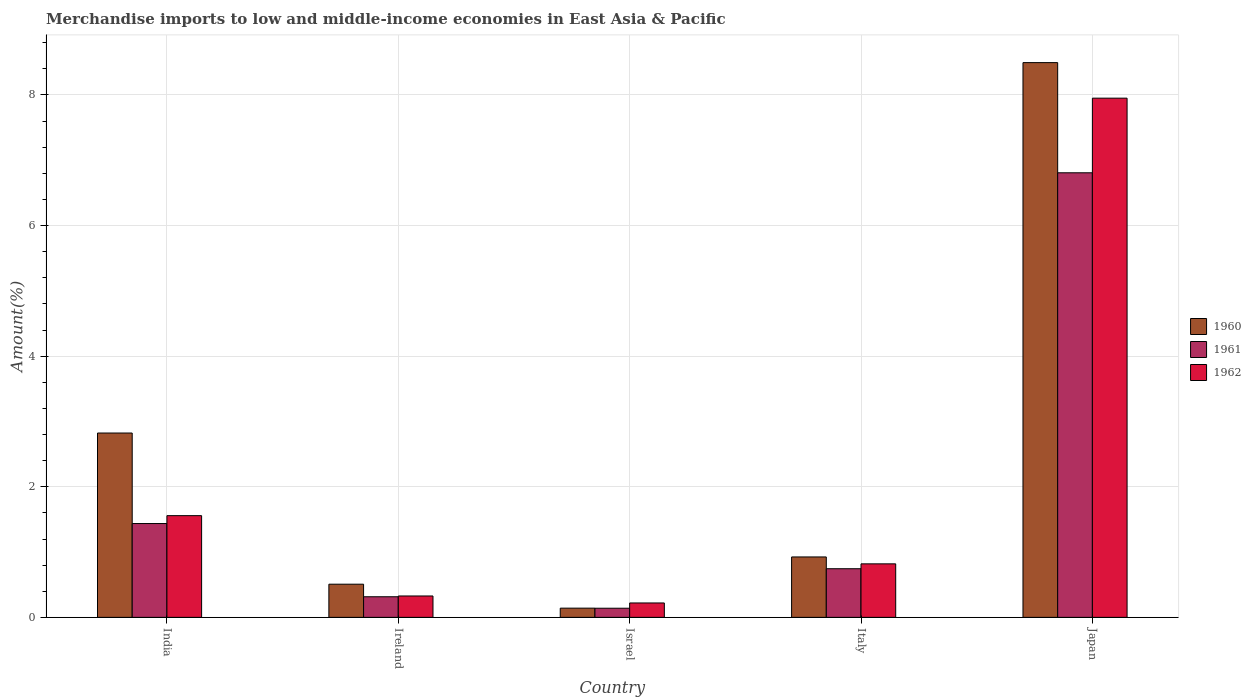How many different coloured bars are there?
Offer a terse response. 3. How many groups of bars are there?
Provide a succinct answer. 5. Are the number of bars per tick equal to the number of legend labels?
Provide a short and direct response. Yes. How many bars are there on the 4th tick from the left?
Provide a short and direct response. 3. How many bars are there on the 3rd tick from the right?
Keep it short and to the point. 3. What is the label of the 3rd group of bars from the left?
Your answer should be very brief. Israel. What is the percentage of amount earned from merchandise imports in 1962 in Japan?
Make the answer very short. 7.95. Across all countries, what is the maximum percentage of amount earned from merchandise imports in 1960?
Your response must be concise. 8.5. Across all countries, what is the minimum percentage of amount earned from merchandise imports in 1962?
Your answer should be very brief. 0.22. In which country was the percentage of amount earned from merchandise imports in 1962 maximum?
Offer a terse response. Japan. What is the total percentage of amount earned from merchandise imports in 1960 in the graph?
Ensure brevity in your answer.  12.89. What is the difference between the percentage of amount earned from merchandise imports in 1961 in Ireland and that in Italy?
Provide a short and direct response. -0.43. What is the difference between the percentage of amount earned from merchandise imports in 1962 in Ireland and the percentage of amount earned from merchandise imports in 1961 in India?
Make the answer very short. -1.11. What is the average percentage of amount earned from merchandise imports in 1962 per country?
Make the answer very short. 2.18. What is the difference between the percentage of amount earned from merchandise imports of/in 1962 and percentage of amount earned from merchandise imports of/in 1961 in Ireland?
Make the answer very short. 0.01. In how many countries, is the percentage of amount earned from merchandise imports in 1960 greater than 6 %?
Make the answer very short. 1. What is the ratio of the percentage of amount earned from merchandise imports in 1962 in Israel to that in Italy?
Offer a very short reply. 0.27. Is the percentage of amount earned from merchandise imports in 1962 in Israel less than that in Italy?
Your response must be concise. Yes. Is the difference between the percentage of amount earned from merchandise imports in 1962 in India and Ireland greater than the difference between the percentage of amount earned from merchandise imports in 1961 in India and Ireland?
Offer a terse response. Yes. What is the difference between the highest and the second highest percentage of amount earned from merchandise imports in 1961?
Your answer should be very brief. -0.69. What is the difference between the highest and the lowest percentage of amount earned from merchandise imports in 1962?
Keep it short and to the point. 7.73. In how many countries, is the percentage of amount earned from merchandise imports in 1961 greater than the average percentage of amount earned from merchandise imports in 1961 taken over all countries?
Provide a succinct answer. 1. What does the 2nd bar from the left in Ireland represents?
Provide a short and direct response. 1961. How many bars are there?
Offer a very short reply. 15. Does the graph contain any zero values?
Your answer should be very brief. No. What is the title of the graph?
Your answer should be very brief. Merchandise imports to low and middle-income economies in East Asia & Pacific. What is the label or title of the X-axis?
Offer a very short reply. Country. What is the label or title of the Y-axis?
Make the answer very short. Amount(%). What is the Amount(%) in 1960 in India?
Offer a very short reply. 2.82. What is the Amount(%) of 1961 in India?
Give a very brief answer. 1.44. What is the Amount(%) of 1962 in India?
Your answer should be compact. 1.56. What is the Amount(%) in 1960 in Ireland?
Your response must be concise. 0.51. What is the Amount(%) in 1961 in Ireland?
Provide a succinct answer. 0.32. What is the Amount(%) of 1962 in Ireland?
Keep it short and to the point. 0.33. What is the Amount(%) of 1960 in Israel?
Provide a short and direct response. 0.14. What is the Amount(%) in 1961 in Israel?
Offer a very short reply. 0.14. What is the Amount(%) of 1962 in Israel?
Your answer should be compact. 0.22. What is the Amount(%) of 1960 in Italy?
Your answer should be very brief. 0.93. What is the Amount(%) in 1961 in Italy?
Offer a very short reply. 0.74. What is the Amount(%) of 1962 in Italy?
Ensure brevity in your answer.  0.82. What is the Amount(%) in 1960 in Japan?
Offer a very short reply. 8.5. What is the Amount(%) in 1961 in Japan?
Provide a succinct answer. 6.81. What is the Amount(%) of 1962 in Japan?
Make the answer very short. 7.95. Across all countries, what is the maximum Amount(%) in 1960?
Keep it short and to the point. 8.5. Across all countries, what is the maximum Amount(%) in 1961?
Ensure brevity in your answer.  6.81. Across all countries, what is the maximum Amount(%) in 1962?
Your answer should be very brief. 7.95. Across all countries, what is the minimum Amount(%) in 1960?
Provide a succinct answer. 0.14. Across all countries, what is the minimum Amount(%) in 1961?
Give a very brief answer. 0.14. Across all countries, what is the minimum Amount(%) of 1962?
Offer a very short reply. 0.22. What is the total Amount(%) in 1960 in the graph?
Provide a short and direct response. 12.89. What is the total Amount(%) in 1961 in the graph?
Give a very brief answer. 9.45. What is the total Amount(%) of 1962 in the graph?
Make the answer very short. 10.88. What is the difference between the Amount(%) in 1960 in India and that in Ireland?
Ensure brevity in your answer.  2.31. What is the difference between the Amount(%) in 1961 in India and that in Ireland?
Offer a terse response. 1.12. What is the difference between the Amount(%) in 1962 in India and that in Ireland?
Make the answer very short. 1.23. What is the difference between the Amount(%) in 1960 in India and that in Israel?
Offer a terse response. 2.68. What is the difference between the Amount(%) of 1961 in India and that in Israel?
Provide a short and direct response. 1.3. What is the difference between the Amount(%) in 1962 in India and that in Israel?
Your answer should be compact. 1.34. What is the difference between the Amount(%) of 1960 in India and that in Italy?
Make the answer very short. 1.9. What is the difference between the Amount(%) in 1961 in India and that in Italy?
Your answer should be very brief. 0.69. What is the difference between the Amount(%) of 1962 in India and that in Italy?
Offer a terse response. 0.74. What is the difference between the Amount(%) in 1960 in India and that in Japan?
Ensure brevity in your answer.  -5.67. What is the difference between the Amount(%) in 1961 in India and that in Japan?
Keep it short and to the point. -5.37. What is the difference between the Amount(%) in 1962 in India and that in Japan?
Provide a succinct answer. -6.39. What is the difference between the Amount(%) in 1960 in Ireland and that in Israel?
Ensure brevity in your answer.  0.37. What is the difference between the Amount(%) in 1961 in Ireland and that in Israel?
Offer a very short reply. 0.18. What is the difference between the Amount(%) of 1962 in Ireland and that in Israel?
Make the answer very short. 0.11. What is the difference between the Amount(%) of 1960 in Ireland and that in Italy?
Offer a terse response. -0.42. What is the difference between the Amount(%) of 1961 in Ireland and that in Italy?
Ensure brevity in your answer.  -0.43. What is the difference between the Amount(%) in 1962 in Ireland and that in Italy?
Offer a terse response. -0.49. What is the difference between the Amount(%) of 1960 in Ireland and that in Japan?
Provide a short and direct response. -7.99. What is the difference between the Amount(%) in 1961 in Ireland and that in Japan?
Provide a succinct answer. -6.49. What is the difference between the Amount(%) of 1962 in Ireland and that in Japan?
Your answer should be compact. -7.62. What is the difference between the Amount(%) of 1960 in Israel and that in Italy?
Provide a succinct answer. -0.78. What is the difference between the Amount(%) in 1961 in Israel and that in Italy?
Provide a succinct answer. -0.6. What is the difference between the Amount(%) in 1962 in Israel and that in Italy?
Provide a succinct answer. -0.6. What is the difference between the Amount(%) of 1960 in Israel and that in Japan?
Provide a short and direct response. -8.35. What is the difference between the Amount(%) in 1961 in Israel and that in Japan?
Your answer should be very brief. -6.67. What is the difference between the Amount(%) of 1962 in Israel and that in Japan?
Offer a terse response. -7.73. What is the difference between the Amount(%) in 1960 in Italy and that in Japan?
Your answer should be compact. -7.57. What is the difference between the Amount(%) of 1961 in Italy and that in Japan?
Keep it short and to the point. -6.06. What is the difference between the Amount(%) of 1962 in Italy and that in Japan?
Your response must be concise. -7.13. What is the difference between the Amount(%) of 1960 in India and the Amount(%) of 1961 in Ireland?
Keep it short and to the point. 2.51. What is the difference between the Amount(%) of 1960 in India and the Amount(%) of 1962 in Ireland?
Ensure brevity in your answer.  2.5. What is the difference between the Amount(%) in 1961 in India and the Amount(%) in 1962 in Ireland?
Provide a short and direct response. 1.11. What is the difference between the Amount(%) of 1960 in India and the Amount(%) of 1961 in Israel?
Keep it short and to the point. 2.68. What is the difference between the Amount(%) of 1960 in India and the Amount(%) of 1962 in Israel?
Ensure brevity in your answer.  2.6. What is the difference between the Amount(%) of 1961 in India and the Amount(%) of 1962 in Israel?
Provide a succinct answer. 1.22. What is the difference between the Amount(%) in 1960 in India and the Amount(%) in 1961 in Italy?
Ensure brevity in your answer.  2.08. What is the difference between the Amount(%) in 1960 in India and the Amount(%) in 1962 in Italy?
Keep it short and to the point. 2. What is the difference between the Amount(%) of 1961 in India and the Amount(%) of 1962 in Italy?
Ensure brevity in your answer.  0.62. What is the difference between the Amount(%) in 1960 in India and the Amount(%) in 1961 in Japan?
Make the answer very short. -3.99. What is the difference between the Amount(%) of 1960 in India and the Amount(%) of 1962 in Japan?
Your response must be concise. -5.13. What is the difference between the Amount(%) of 1961 in India and the Amount(%) of 1962 in Japan?
Keep it short and to the point. -6.51. What is the difference between the Amount(%) of 1960 in Ireland and the Amount(%) of 1961 in Israel?
Make the answer very short. 0.37. What is the difference between the Amount(%) in 1960 in Ireland and the Amount(%) in 1962 in Israel?
Your answer should be compact. 0.29. What is the difference between the Amount(%) in 1961 in Ireland and the Amount(%) in 1962 in Israel?
Make the answer very short. 0.1. What is the difference between the Amount(%) in 1960 in Ireland and the Amount(%) in 1961 in Italy?
Ensure brevity in your answer.  -0.24. What is the difference between the Amount(%) of 1960 in Ireland and the Amount(%) of 1962 in Italy?
Give a very brief answer. -0.31. What is the difference between the Amount(%) in 1961 in Ireland and the Amount(%) in 1962 in Italy?
Offer a terse response. -0.5. What is the difference between the Amount(%) of 1960 in Ireland and the Amount(%) of 1961 in Japan?
Make the answer very short. -6.3. What is the difference between the Amount(%) in 1960 in Ireland and the Amount(%) in 1962 in Japan?
Provide a succinct answer. -7.44. What is the difference between the Amount(%) in 1961 in Ireland and the Amount(%) in 1962 in Japan?
Ensure brevity in your answer.  -7.64. What is the difference between the Amount(%) of 1960 in Israel and the Amount(%) of 1961 in Italy?
Make the answer very short. -0.6. What is the difference between the Amount(%) of 1960 in Israel and the Amount(%) of 1962 in Italy?
Provide a short and direct response. -0.68. What is the difference between the Amount(%) of 1961 in Israel and the Amount(%) of 1962 in Italy?
Your answer should be compact. -0.68. What is the difference between the Amount(%) in 1960 in Israel and the Amount(%) in 1961 in Japan?
Give a very brief answer. -6.67. What is the difference between the Amount(%) of 1960 in Israel and the Amount(%) of 1962 in Japan?
Your response must be concise. -7.81. What is the difference between the Amount(%) of 1961 in Israel and the Amount(%) of 1962 in Japan?
Keep it short and to the point. -7.81. What is the difference between the Amount(%) in 1960 in Italy and the Amount(%) in 1961 in Japan?
Provide a succinct answer. -5.88. What is the difference between the Amount(%) of 1960 in Italy and the Amount(%) of 1962 in Japan?
Keep it short and to the point. -7.03. What is the difference between the Amount(%) in 1961 in Italy and the Amount(%) in 1962 in Japan?
Your response must be concise. -7.21. What is the average Amount(%) in 1960 per country?
Keep it short and to the point. 2.58. What is the average Amount(%) of 1961 per country?
Make the answer very short. 1.89. What is the average Amount(%) of 1962 per country?
Make the answer very short. 2.18. What is the difference between the Amount(%) in 1960 and Amount(%) in 1961 in India?
Your answer should be very brief. 1.39. What is the difference between the Amount(%) in 1960 and Amount(%) in 1962 in India?
Keep it short and to the point. 1.27. What is the difference between the Amount(%) in 1961 and Amount(%) in 1962 in India?
Ensure brevity in your answer.  -0.12. What is the difference between the Amount(%) in 1960 and Amount(%) in 1961 in Ireland?
Ensure brevity in your answer.  0.19. What is the difference between the Amount(%) in 1960 and Amount(%) in 1962 in Ireland?
Give a very brief answer. 0.18. What is the difference between the Amount(%) in 1961 and Amount(%) in 1962 in Ireland?
Your answer should be compact. -0.01. What is the difference between the Amount(%) in 1960 and Amount(%) in 1961 in Israel?
Your answer should be compact. 0. What is the difference between the Amount(%) of 1960 and Amount(%) of 1962 in Israel?
Provide a succinct answer. -0.08. What is the difference between the Amount(%) of 1961 and Amount(%) of 1962 in Israel?
Make the answer very short. -0.08. What is the difference between the Amount(%) of 1960 and Amount(%) of 1961 in Italy?
Give a very brief answer. 0.18. What is the difference between the Amount(%) in 1960 and Amount(%) in 1962 in Italy?
Your answer should be very brief. 0.11. What is the difference between the Amount(%) in 1961 and Amount(%) in 1962 in Italy?
Give a very brief answer. -0.07. What is the difference between the Amount(%) of 1960 and Amount(%) of 1961 in Japan?
Offer a very short reply. 1.69. What is the difference between the Amount(%) in 1960 and Amount(%) in 1962 in Japan?
Offer a terse response. 0.54. What is the difference between the Amount(%) of 1961 and Amount(%) of 1962 in Japan?
Ensure brevity in your answer.  -1.14. What is the ratio of the Amount(%) of 1960 in India to that in Ireland?
Provide a short and direct response. 5.56. What is the ratio of the Amount(%) of 1961 in India to that in Ireland?
Your answer should be very brief. 4.55. What is the ratio of the Amount(%) of 1962 in India to that in Ireland?
Ensure brevity in your answer.  4.76. What is the ratio of the Amount(%) in 1960 in India to that in Israel?
Offer a terse response. 20.01. What is the ratio of the Amount(%) in 1961 in India to that in Israel?
Your answer should be compact. 10.28. What is the ratio of the Amount(%) of 1962 in India to that in Israel?
Ensure brevity in your answer.  7.06. What is the ratio of the Amount(%) in 1960 in India to that in Italy?
Your answer should be very brief. 3.05. What is the ratio of the Amount(%) in 1961 in India to that in Italy?
Provide a succinct answer. 1.93. What is the ratio of the Amount(%) of 1962 in India to that in Italy?
Provide a succinct answer. 1.9. What is the ratio of the Amount(%) in 1960 in India to that in Japan?
Ensure brevity in your answer.  0.33. What is the ratio of the Amount(%) of 1961 in India to that in Japan?
Offer a terse response. 0.21. What is the ratio of the Amount(%) in 1962 in India to that in Japan?
Offer a terse response. 0.2. What is the ratio of the Amount(%) of 1960 in Ireland to that in Israel?
Make the answer very short. 3.6. What is the ratio of the Amount(%) of 1961 in Ireland to that in Israel?
Give a very brief answer. 2.26. What is the ratio of the Amount(%) of 1962 in Ireland to that in Israel?
Your answer should be compact. 1.48. What is the ratio of the Amount(%) of 1960 in Ireland to that in Italy?
Provide a short and direct response. 0.55. What is the ratio of the Amount(%) in 1961 in Ireland to that in Italy?
Give a very brief answer. 0.42. What is the ratio of the Amount(%) in 1962 in Ireland to that in Italy?
Your answer should be compact. 0.4. What is the ratio of the Amount(%) of 1960 in Ireland to that in Japan?
Your response must be concise. 0.06. What is the ratio of the Amount(%) of 1961 in Ireland to that in Japan?
Your response must be concise. 0.05. What is the ratio of the Amount(%) in 1962 in Ireland to that in Japan?
Provide a short and direct response. 0.04. What is the ratio of the Amount(%) in 1960 in Israel to that in Italy?
Make the answer very short. 0.15. What is the ratio of the Amount(%) in 1961 in Israel to that in Italy?
Your response must be concise. 0.19. What is the ratio of the Amount(%) in 1962 in Israel to that in Italy?
Make the answer very short. 0.27. What is the ratio of the Amount(%) in 1960 in Israel to that in Japan?
Keep it short and to the point. 0.02. What is the ratio of the Amount(%) in 1961 in Israel to that in Japan?
Your answer should be compact. 0.02. What is the ratio of the Amount(%) of 1962 in Israel to that in Japan?
Give a very brief answer. 0.03. What is the ratio of the Amount(%) in 1960 in Italy to that in Japan?
Offer a very short reply. 0.11. What is the ratio of the Amount(%) in 1961 in Italy to that in Japan?
Ensure brevity in your answer.  0.11. What is the ratio of the Amount(%) of 1962 in Italy to that in Japan?
Ensure brevity in your answer.  0.1. What is the difference between the highest and the second highest Amount(%) in 1960?
Provide a short and direct response. 5.67. What is the difference between the highest and the second highest Amount(%) in 1961?
Keep it short and to the point. 5.37. What is the difference between the highest and the second highest Amount(%) of 1962?
Your answer should be compact. 6.39. What is the difference between the highest and the lowest Amount(%) of 1960?
Offer a terse response. 8.35. What is the difference between the highest and the lowest Amount(%) in 1961?
Give a very brief answer. 6.67. What is the difference between the highest and the lowest Amount(%) in 1962?
Ensure brevity in your answer.  7.73. 